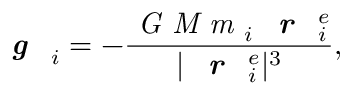<formula> <loc_0><loc_0><loc_500><loc_500>g _ { i } = - \frac { G M m _ { i } r _ { i } ^ { e } } { | r _ { i } ^ { e } | ^ { 3 } } ,</formula> 